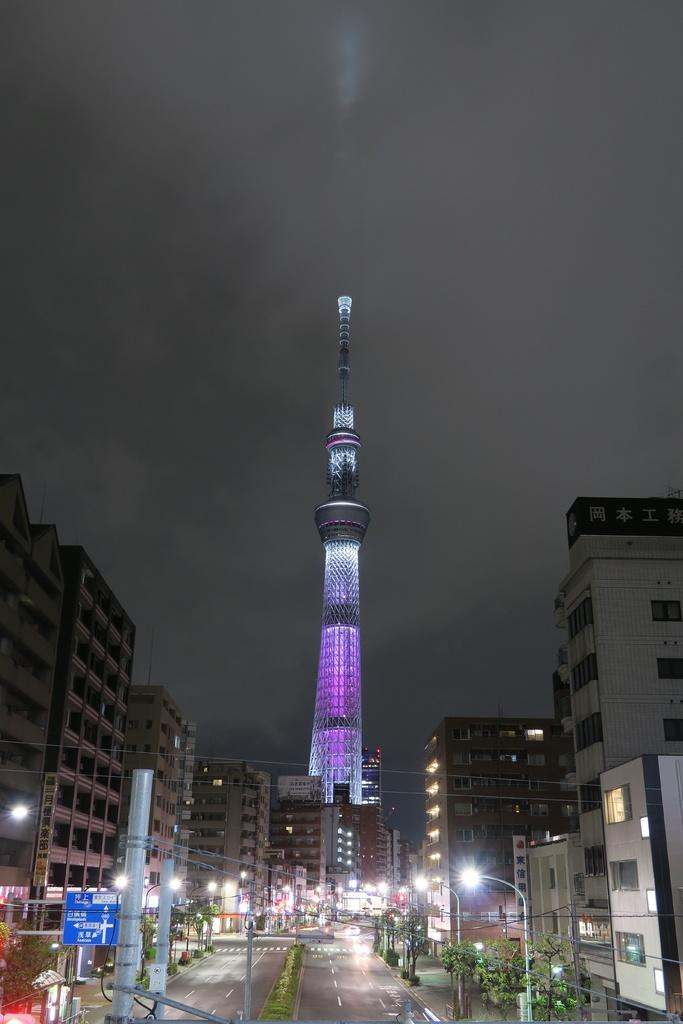What type of structures are located in the foreground of the image? There are buildings in the foreground of the image. What type of tall building can be seen in the background of the image? There is a skyscraper in the background of the image. What are the poles used for in the image? The purpose of the poles in the image is not specified, but they could be for streetlights, traffic signals, or other purposes. What type of vegetation is present in the image? There are trees in the image. What type of pathway is visible in the image? There is a road in the image. What part of the natural environment is visible in the image? The sky is visible in the image. How many pipes can be seen running along the ground in the image? There are no pipes visible in the image; it features buildings, a skyscraper, poles, trees, a road, and the sky. What time of day is it in the image, based on the hour? The image does not provide any information about the time of day, and there is no mention of an hour in the facts provided. 